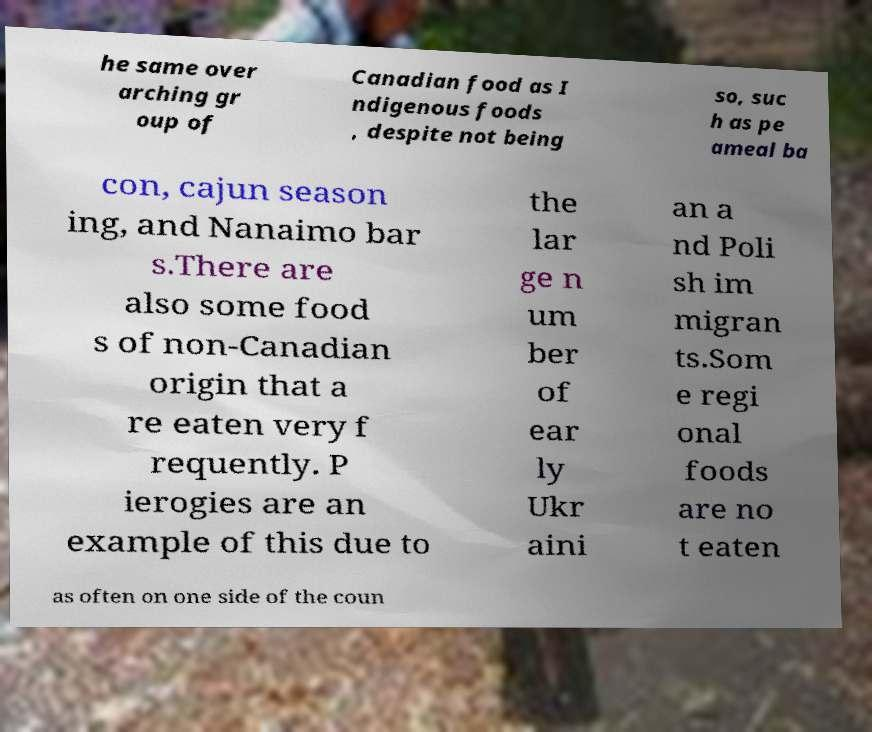For documentation purposes, I need the text within this image transcribed. Could you provide that? he same over arching gr oup of Canadian food as I ndigenous foods , despite not being so, suc h as pe ameal ba con, cajun season ing, and Nanaimo bar s.There are also some food s of non-Canadian origin that a re eaten very f requently. P ierogies are an example of this due to the lar ge n um ber of ear ly Ukr aini an a nd Poli sh im migran ts.Som e regi onal foods are no t eaten as often on one side of the coun 